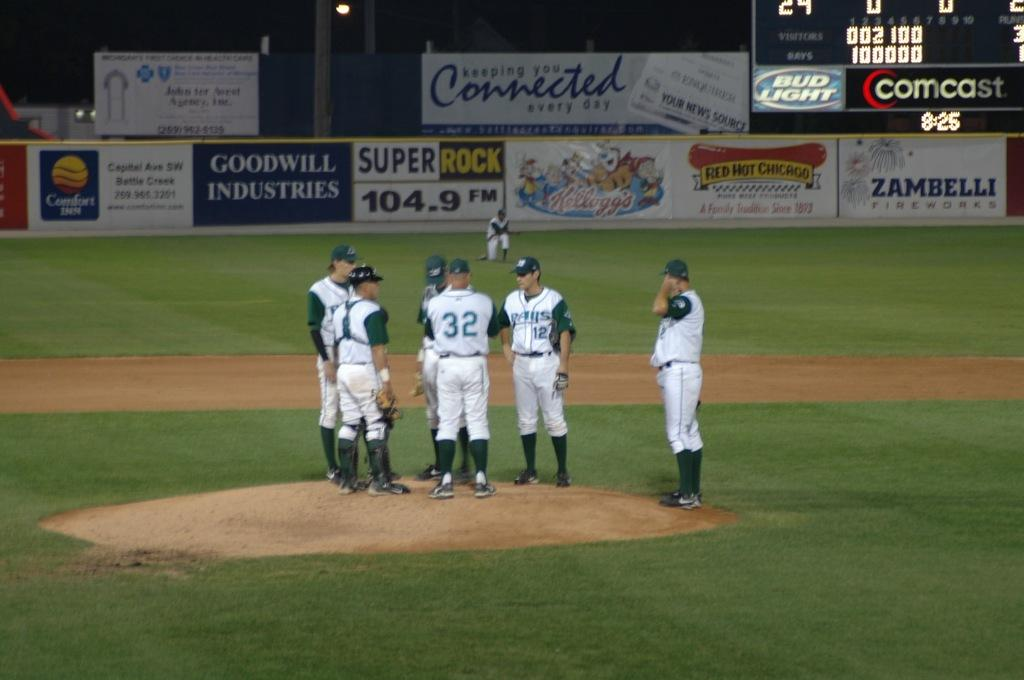<image>
Provide a brief description of the given image. A team stand on the field and in the background there is an advertisement for Goodwill Industries. 